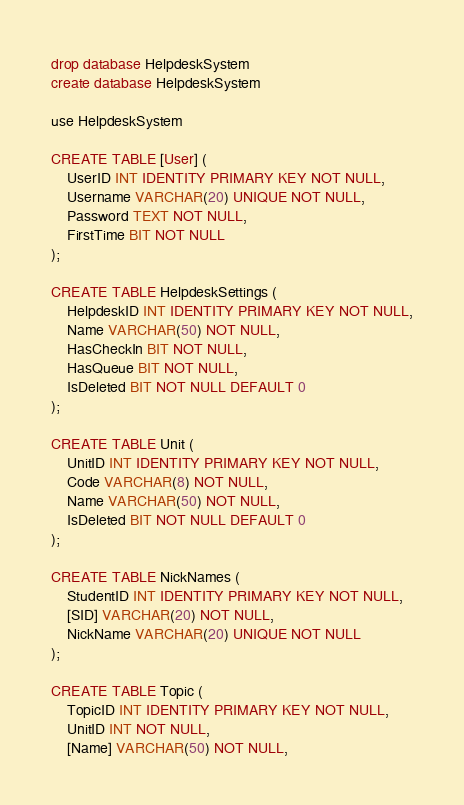<code> <loc_0><loc_0><loc_500><loc_500><_SQL_>drop database HelpdeskSystem
create database HelpdeskSystem

use HelpdeskSystem

CREATE TABLE [User] (
    UserID INT IDENTITY PRIMARY KEY NOT NULL,
    Username VARCHAR(20) UNIQUE NOT NULL,
    Password TEXT NOT NULL,
    FirstTime BIT NOT NULL
);

CREATE TABLE HelpdeskSettings (
    HelpdeskID INT IDENTITY PRIMARY KEY NOT NULL,
    Name VARCHAR(50) NOT NULL,
    HasCheckIn BIT NOT NULL,
    HasQueue BIT NOT NULL,
    IsDeleted BIT NOT NULL DEFAULT 0
);

CREATE TABLE Unit (
    UnitID INT IDENTITY PRIMARY KEY NOT NULL,
    Code VARCHAR(8) NOT NULL,
    Name VARCHAR(50) NOT NULL,
    IsDeleted BIT NOT NULL DEFAULT 0
);

CREATE TABLE NickNames (
    StudentID INT IDENTITY PRIMARY KEY NOT NULL,
    [SID] VARCHAR(20) NOT NULL,
    NickName VARCHAR(20) UNIQUE NOT NULL
);

CREATE TABLE Topic (
    TopicID INT IDENTITY PRIMARY KEY NOT NULL,
    UnitID INT NOT NULL,
    [Name] VARCHAR(50) NOT NULL,</code> 